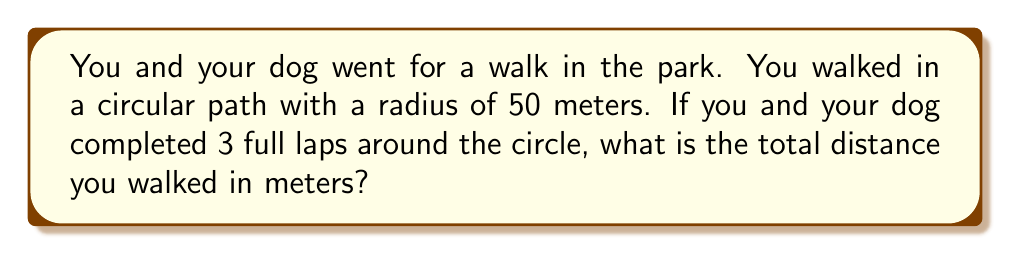Show me your answer to this math problem. Let's break this down step-by-step:

1) First, we need to recall the formula for the circumference of a circle:
   
   $$C = 2\pi r$$
   
   Where $C$ is the circumference, $\pi$ is pi (approximately 3.14159), and $r$ is the radius.

2) We're given that the radius of the circular path is 50 meters. Let's substitute this into our formula:
   
   $$C = 2\pi (50)$$

3) Let's calculate this:
   
   $$C = 100\pi \approx 314.16 \text{ meters}$$

4) This is the distance for one lap around the circle. But you and your dog completed 3 full laps.

5) To get the total distance, we multiply the circumference by 3:
   
   $$\text{Total Distance} = 3 \times 100\pi = 300\pi \approx 942.48 \text{ meters}$$

Therefore, you and your dog walked approximately 942.48 meters in total.
Answer: $300\pi$ meters or approximately 942.48 meters 